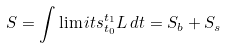<formula> <loc_0><loc_0><loc_500><loc_500>S = \int \lim i t s _ { t _ { 0 } } ^ { t _ { 1 } } L \, d t = S _ { b } + S _ { s }</formula> 